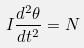Convert formula to latex. <formula><loc_0><loc_0><loc_500><loc_500>I \frac { d ^ { 2 } \theta } { d t ^ { 2 } } = N</formula> 